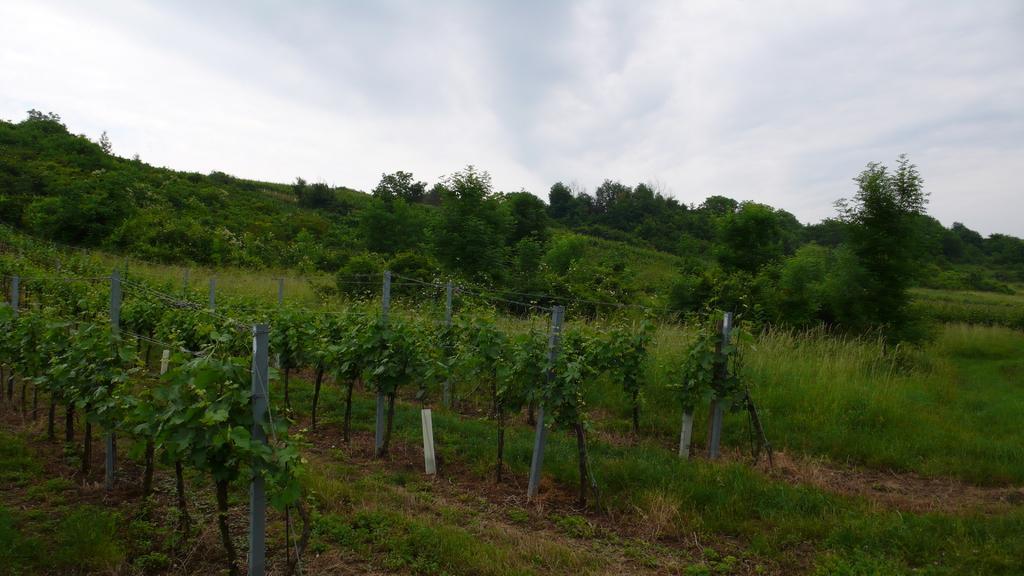In one or two sentences, can you explain what this image depicts? In this image, we can see few plants, grass, poles, trees. Background there is a sky. 